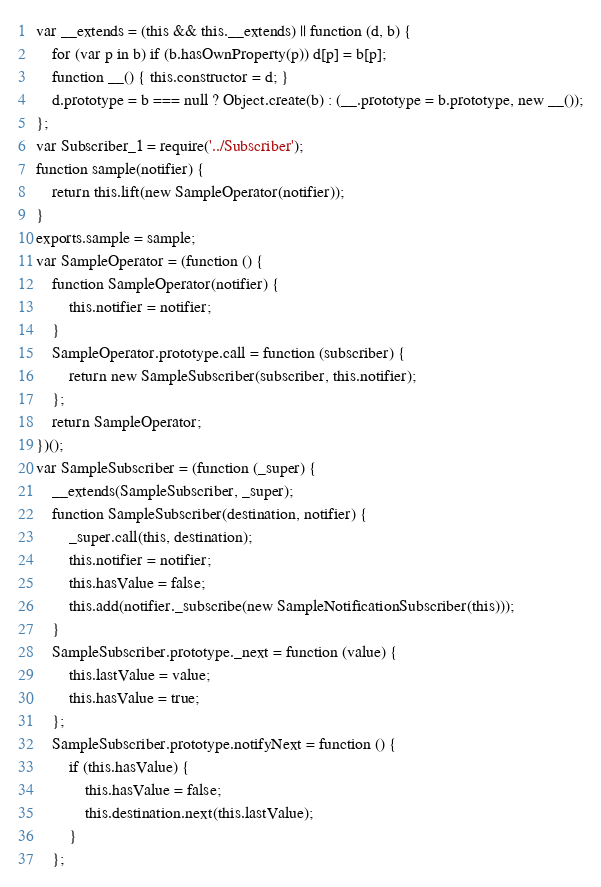Convert code to text. <code><loc_0><loc_0><loc_500><loc_500><_JavaScript_>var __extends = (this && this.__extends) || function (d, b) {
    for (var p in b) if (b.hasOwnProperty(p)) d[p] = b[p];
    function __() { this.constructor = d; }
    d.prototype = b === null ? Object.create(b) : (__.prototype = b.prototype, new __());
};
var Subscriber_1 = require('../Subscriber');
function sample(notifier) {
    return this.lift(new SampleOperator(notifier));
}
exports.sample = sample;
var SampleOperator = (function () {
    function SampleOperator(notifier) {
        this.notifier = notifier;
    }
    SampleOperator.prototype.call = function (subscriber) {
        return new SampleSubscriber(subscriber, this.notifier);
    };
    return SampleOperator;
})();
var SampleSubscriber = (function (_super) {
    __extends(SampleSubscriber, _super);
    function SampleSubscriber(destination, notifier) {
        _super.call(this, destination);
        this.notifier = notifier;
        this.hasValue = false;
        this.add(notifier._subscribe(new SampleNotificationSubscriber(this)));
    }
    SampleSubscriber.prototype._next = function (value) {
        this.lastValue = value;
        this.hasValue = true;
    };
    SampleSubscriber.prototype.notifyNext = function () {
        if (this.hasValue) {
            this.hasValue = false;
            this.destination.next(this.lastValue);
        }
    };</code> 